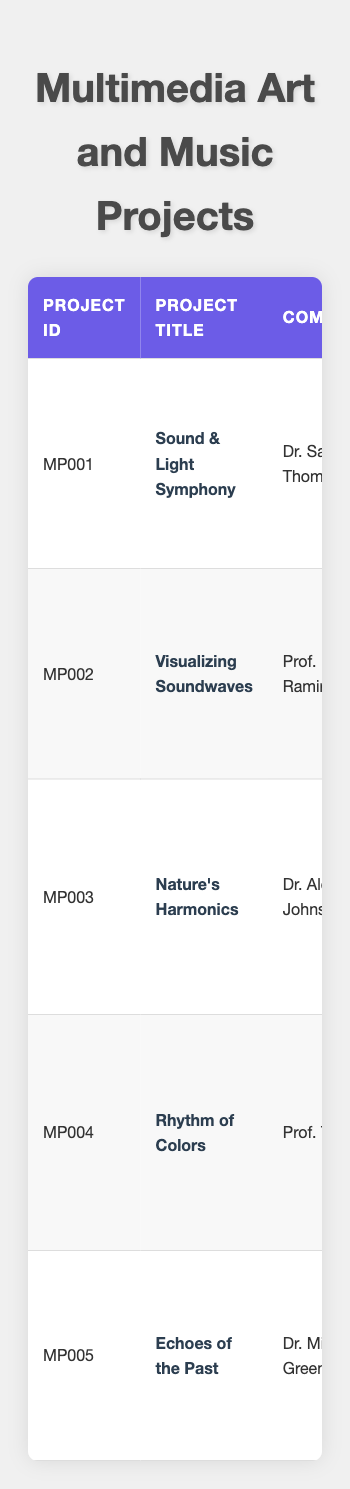What is the total budget for all multimedia projects? The budgets are: $12,000 (MP001) + $8,000 (MP002) + $15,000 (MP003) + $5,000 (MP004) + $20,000 (MP005). Summing these gives a total of $12,000 + $8,000 + $15,000 + $5,000 + $20,000 = $60,000.
Answer: $60,000 Which project had the longest duration and how many months was it? The project durations are: 6 (MP001), 4 (MP002), 8 (MP003), 3 (MP004), and 10 (MP005). The longest duration is 10 months for "Echoes of the Past" (MP005).
Answer: 10 months Did any project use "Adobe After Effects"? "Sound & Light Symphony" (MP001) is the only project listed that used "Adobe After Effects". Therefore, the answer is yes.
Answer: Yes What is the average project duration in months? The total duration is 6 (MP001) + 4 (MP002) + 8 (MP003) + 3 (MP004) + 10 (MP005) = 31 months. There are 5 projects, so the average is 31 months / 5 = 6.2 months.
Answer: 6.2 months Which visual artist collaborated with Dr. Michael Green? The visual artist listed for "Echoes of the Past" (MP005) is Professor Anna White.
Answer: Professor Anna White How many projects used "FL Studio"? Only "Rhythm of Colors" (MP004) is listed to have used "FL Studio". Therefore, the count is 1 project.
Answer: 1 project What is the relationship between project budgets and their collaboration types? Looking at the projects, the budgets vary as follows: $12,000 (Live Performance), $8,000 (Gallery Exhibition), $15,000 (Interactive Installation), $5,000 (Multimedia Workshop), $20,000 (Installation & Performance). No specific pattern in collaboration types correlates directly with budget.
Answer: No specific relationship Which two projects had the highest combined budget? The two highest budgets are $20,000 (MP005) and $15,000 (MP003). Their combined budget is $20,000 + $15,000 = $35,000 for "Echoes of the Past" and "Nature's Harmonics".
Answer: $35,000 How many unique software programs were used across all projects? The software programs are: Adobe After Effects, Processing, Unity, Logic Pro X, Final Cut Pro, MAX/MSP Jitter, Adobe Premiere Pro, TouchDesigner, Reaper, Adobe Illustrator, Final Draft, Noteflight, FL Studio, ArcGIS StoryMaps, Adobe Photoshop, Cinema 4D, Cubase, Procreate, Notion, and Serato DJ. Counting these unique entries gives 20 different software programs.
Answer: 20 software programs What type of installation was associated with the least budget? "Rhythm of Colors" (MP004) has the least budget at $5,000, which is associated with a Multimedia Workshop.
Answer: Multimedia Workshop Which project includes a Canon EOS 5D Mark IV? The project titled "Visualizing Soundwaves" (MP002) is the one that used a Canon EOS 5D Mark IV.
Answer: Visualizing Soundwaves 